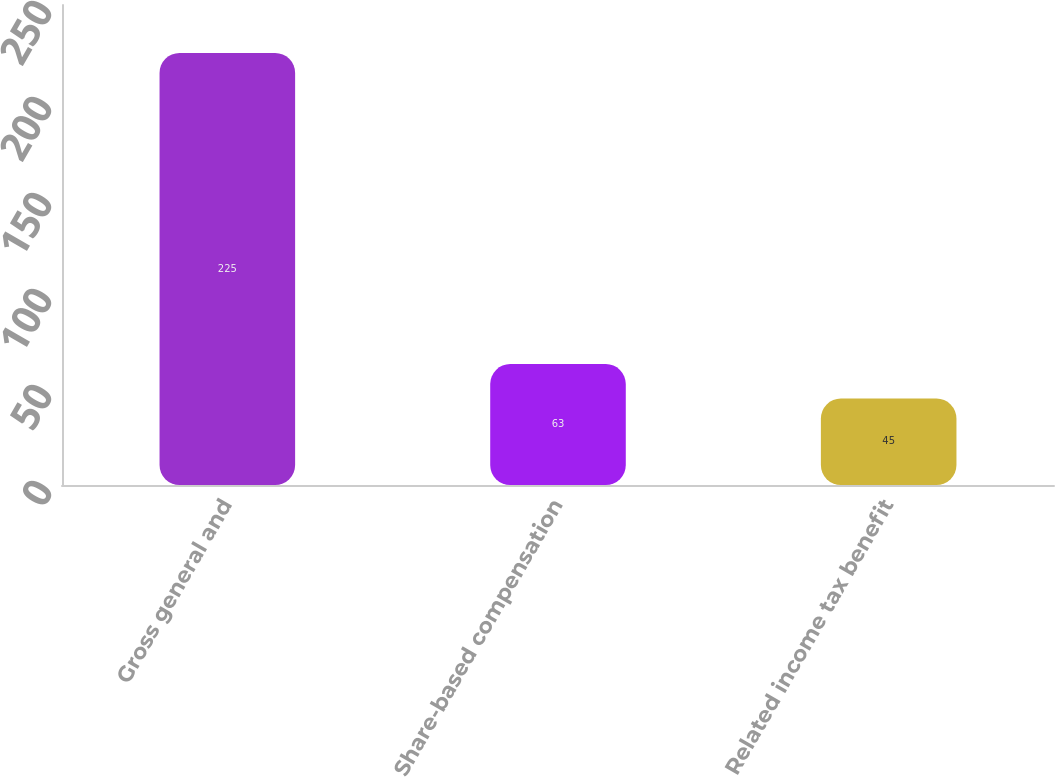<chart> <loc_0><loc_0><loc_500><loc_500><bar_chart><fcel>Gross general and<fcel>Share-based compensation<fcel>Related income tax benefit<nl><fcel>225<fcel>63<fcel>45<nl></chart> 